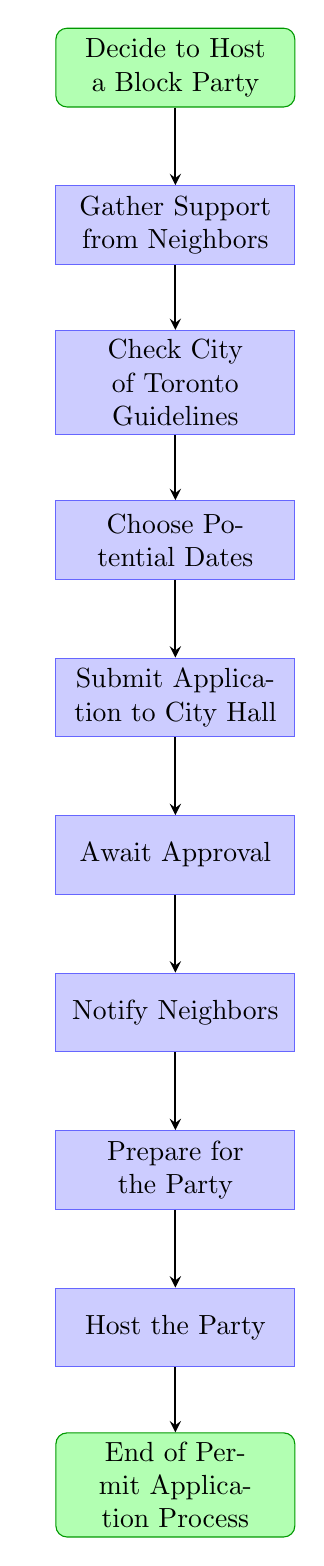What is the first step in the process? The first step in the diagram is indicated at the top, which shows "Decide to Host a Block Party" as the starting point of the flow.
Answer: Decide to Host a Block Party How many main steps are there in the block party process? Counting the steps displayed in the diagram, there are eight main process steps from "Gather Support from Neighbors" to "Host the Party."
Answer: Eight What action follows "Check City of Toronto Guidelines"? The flow indicates that the next action after "Check City of Toronto Guidelines" is "Choose Potential Dates" according to the directional arrows showing the sequence.
Answer: Choose Potential Dates What is the final step in the permit application process? The final step is located at the bottom of the diagram, represented by "End of Permit Application Process," marking the conclusion of the entire process.
Answer: End of Permit Application Process Which step involves interaction with City Hall? The interaction with City Hall is specifically detailed in the step "Submit Application to City Hall," which is the fourth step in the flow sequence.
Answer: Submit Application to City Hall What must be done before notifying neighbors? Before notifying neighbors, the preceding step "Await Approval" must be completed, as indicated by the flow leading from one action directly to the next.
Answer: Await Approval Which step comes directly after "Gather Support from Neighbors"? According to the flow order, the step that comes directly after "Gather Support from Neighbors" is "Check City of Toronto Guidelines."
Answer: Check City of Toronto Guidelines How many actions are taken after getting approval from City Hall? After getting approval from City Hall, there are three actions taken: "Notify Neighbors," "Prepare for the Party," and "Host the Party." Counting these sequentially gives three actions.
Answer: Three 